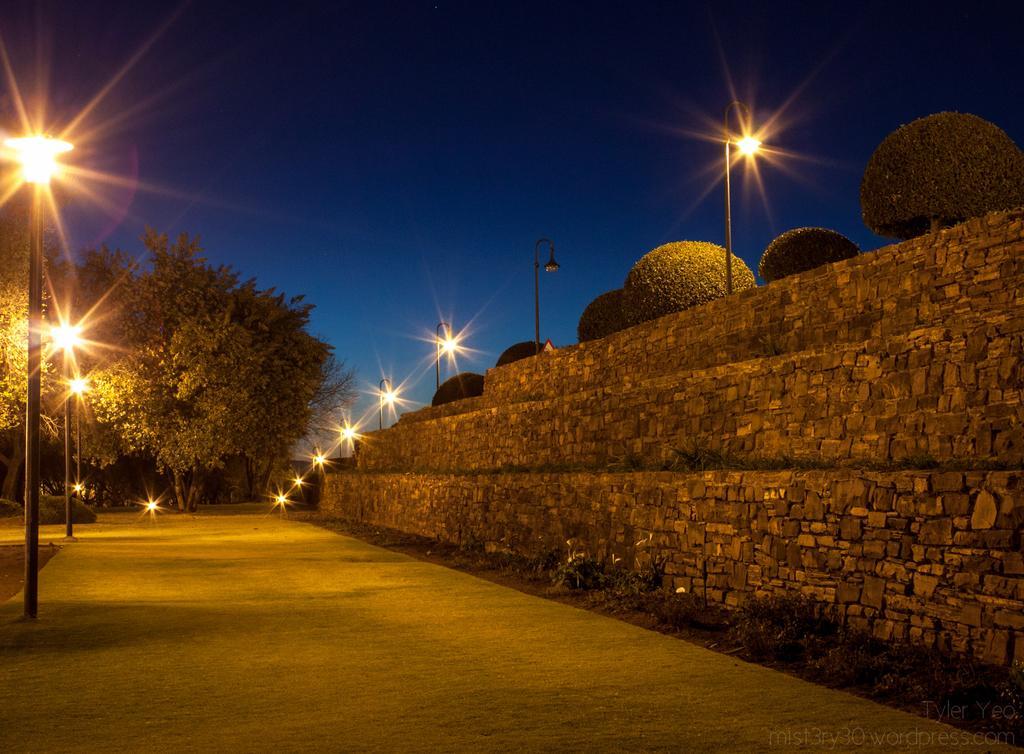In one or two sentences, can you explain what this image depicts? In the image there is road in the middle with street lights on either side of it and behind there are trees and above its sky. 